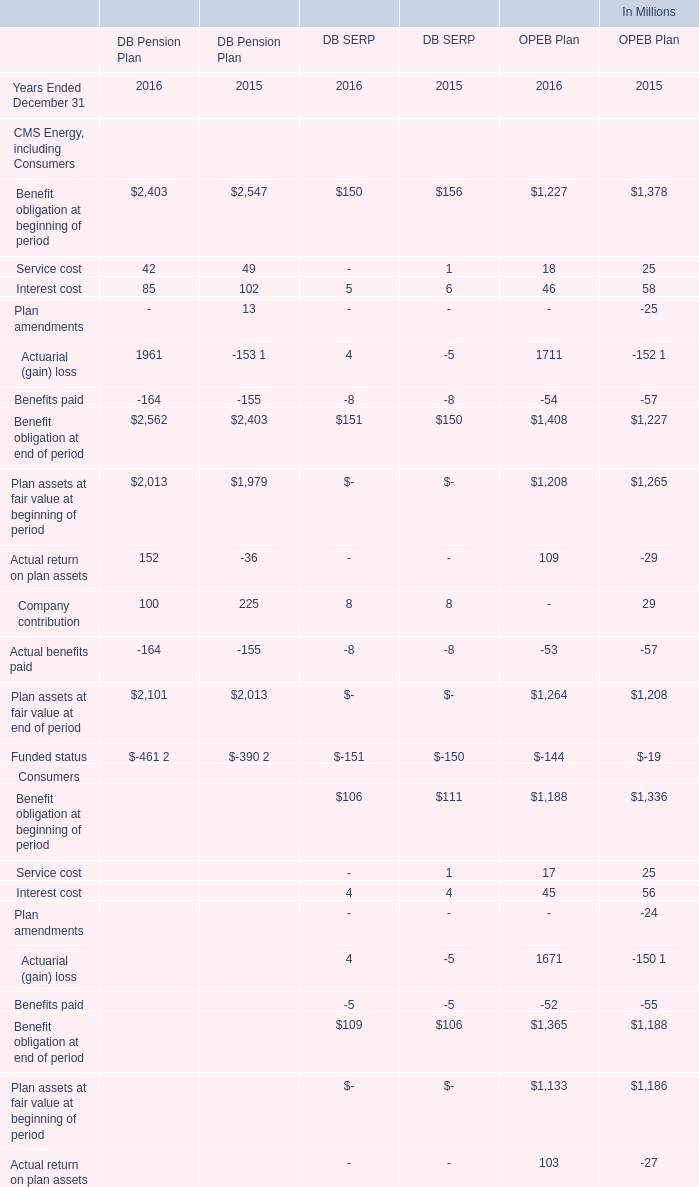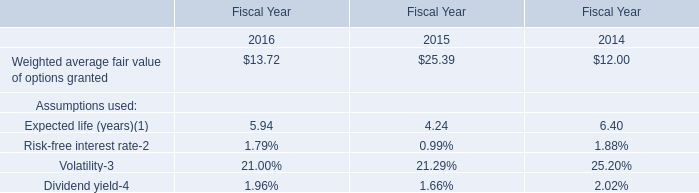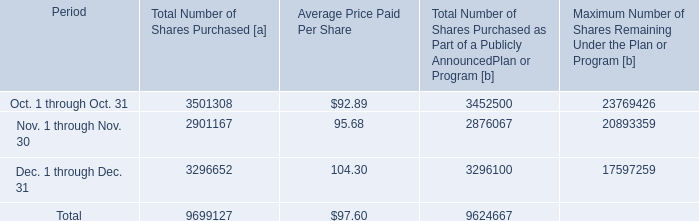during 2016 what was the percent of the number of shares bought in the fourth quarter 
Computations: (9699127 / 35686529)
Answer: 0.27179. 